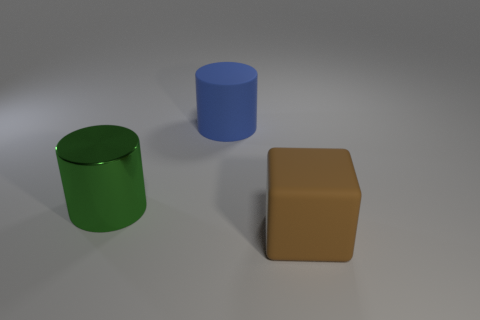Are there any other things that are made of the same material as the big green object?
Your answer should be compact. No. How many green metallic objects are the same size as the matte cube?
Provide a short and direct response. 1. Is there another large object that has the same shape as the green object?
Make the answer very short. Yes. There is a block that is the same size as the blue matte cylinder; what color is it?
Ensure brevity in your answer.  Brown. The cylinder on the left side of the blue rubber cylinder that is to the right of the large green cylinder is what color?
Make the answer very short. Green. What is the shape of the object on the left side of the large rubber object that is behind the large object that is in front of the big green metallic object?
Your answer should be very brief. Cylinder. There is a large matte object that is in front of the big blue matte cylinder; what number of big metal things are to the left of it?
Ensure brevity in your answer.  1. Are the large green thing and the large brown object made of the same material?
Make the answer very short. No. What number of big things are on the right side of the green cylinder that is in front of the cylinder behind the metal object?
Your answer should be very brief. 2. What is the color of the rubber object that is behind the cube?
Your response must be concise. Blue. 